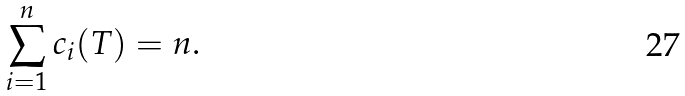<formula> <loc_0><loc_0><loc_500><loc_500>\sum _ { i = 1 } ^ { n } c _ { i } ( T ) = n .</formula> 